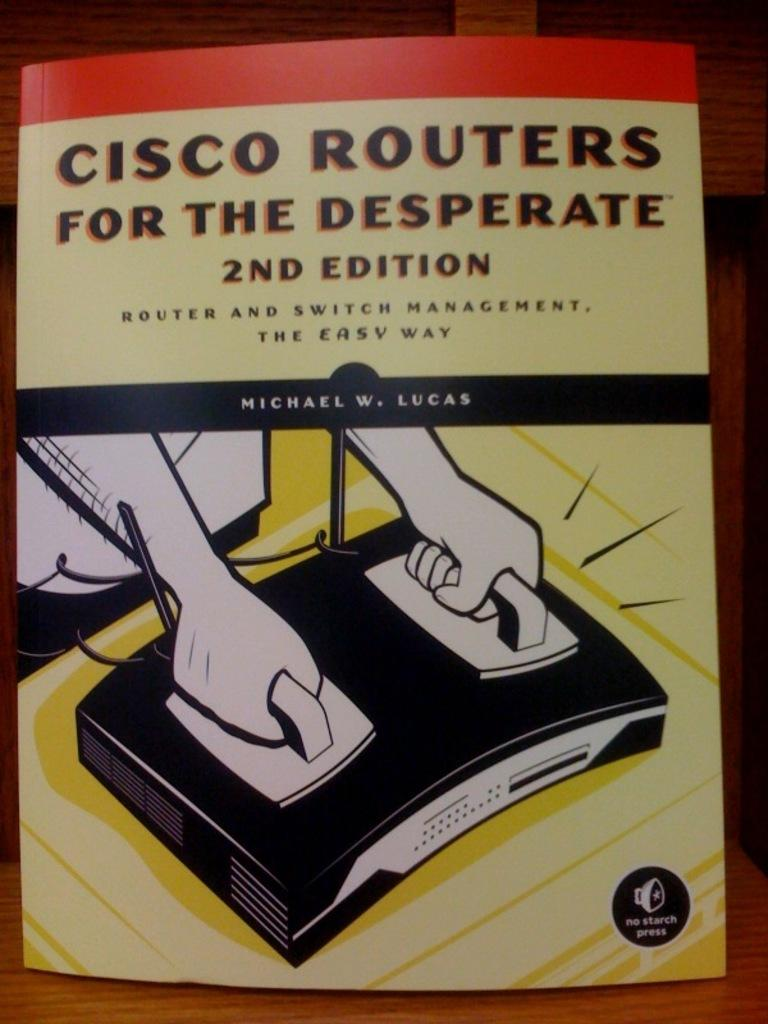Provide a one-sentence caption for the provided image. A computer reference book takes a humorous approach to routers and switch management. 